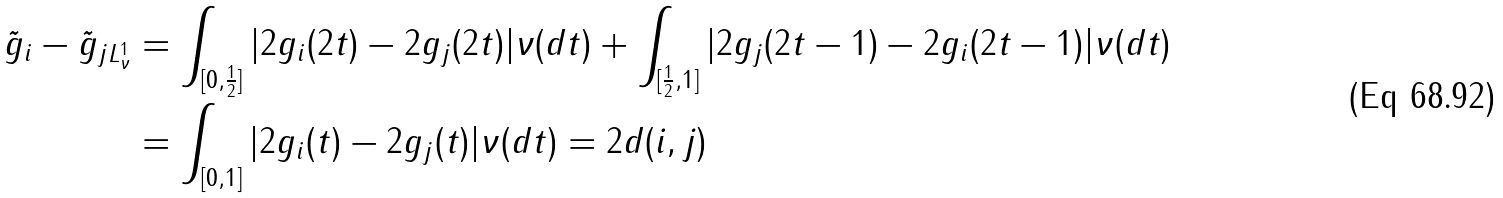Convert formula to latex. <formula><loc_0><loc_0><loc_500><loc_500>\| \tilde { g } _ { i } - \tilde { g } _ { j } \| _ { L _ { \nu } ^ { 1 } } & = \int _ { [ 0 , \frac { 1 } { 2 } ] } | 2 g _ { i } ( 2 t ) - 2 g _ { j } ( 2 t ) | \nu ( d t ) + \int _ { [ \frac { 1 } { 2 } , 1 ] } | 2 g _ { j } ( 2 t - 1 ) - 2 g _ { i } ( 2 t - 1 ) | \nu ( d t ) \\ & = \int _ { [ 0 , 1 ] } | 2 g _ { i } ( t ) - 2 g _ { j } ( t ) | \nu ( d t ) = 2 d ( i , j )</formula> 